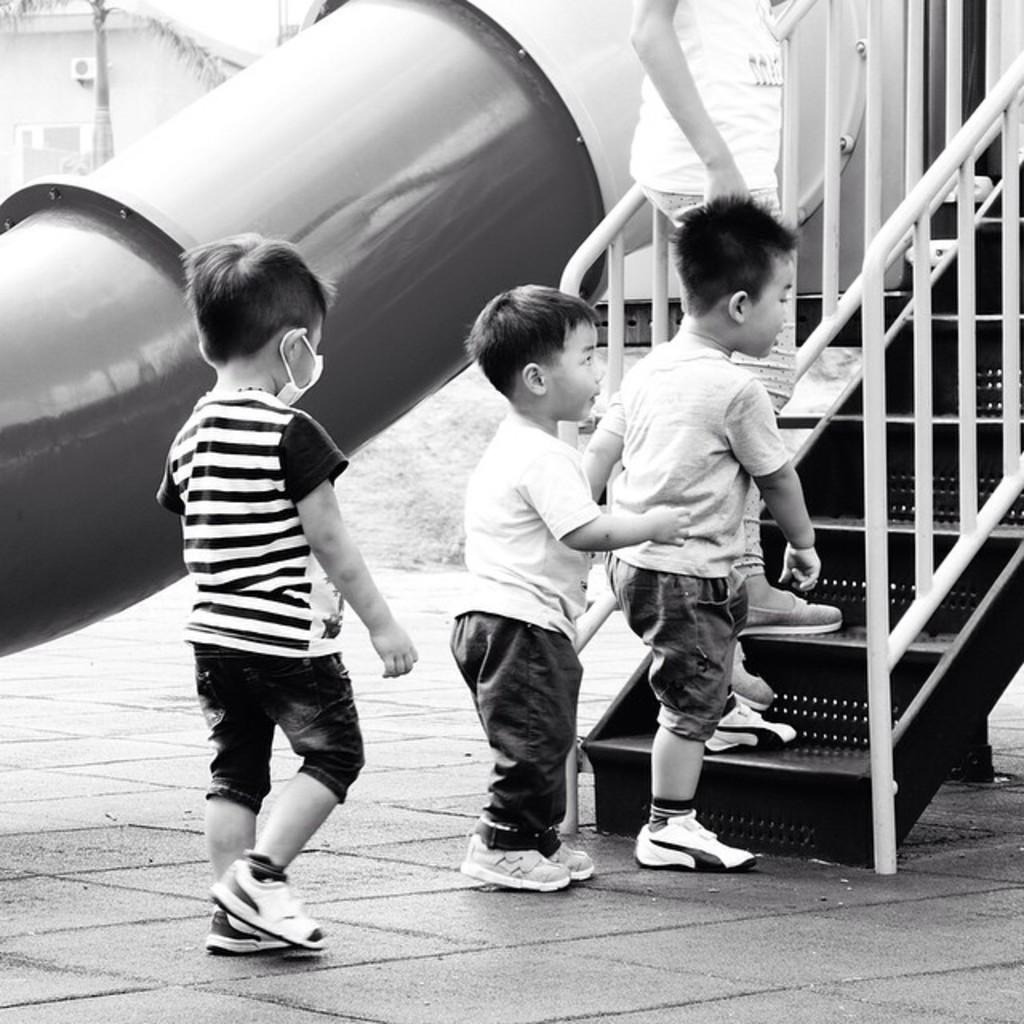What is the color scheme of the image? The image is black and white. How many kids are present in the image? There are 3 kids in the image. What are the kids doing in the image? The kids are entering through a staircase. What type of brush can be seen in the image? There is no brush present in the image. Is there snow visible in the image? No, there is no snow visible in the image. 